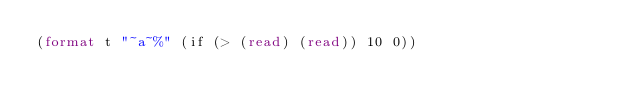Convert code to text. <code><loc_0><loc_0><loc_500><loc_500><_Lisp_>(format t "~a~%" (if (> (read) (read)) 10 0))</code> 